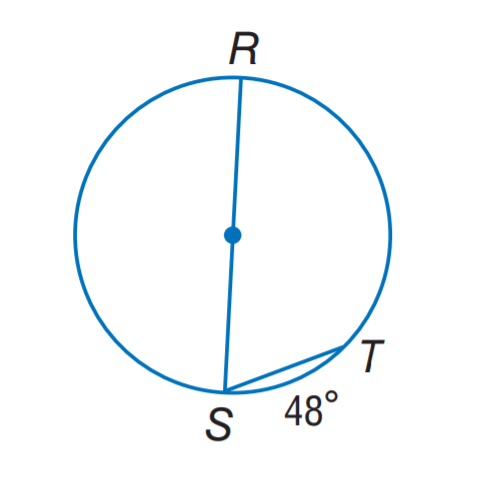Answer the mathemtical geometry problem and directly provide the correct option letter.
Question: Find m \angle S.
Choices: A: 24 B: 48 C: 66 D: 78 C 